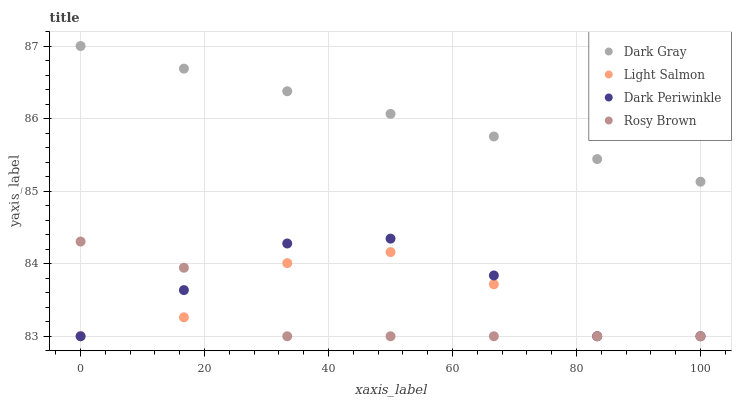Does Rosy Brown have the minimum area under the curve?
Answer yes or no. Yes. Does Dark Gray have the maximum area under the curve?
Answer yes or no. Yes. Does Light Salmon have the minimum area under the curve?
Answer yes or no. No. Does Light Salmon have the maximum area under the curve?
Answer yes or no. No. Is Dark Gray the smoothest?
Answer yes or no. Yes. Is Light Salmon the roughest?
Answer yes or no. Yes. Is Rosy Brown the smoothest?
Answer yes or no. No. Is Rosy Brown the roughest?
Answer yes or no. No. Does Light Salmon have the lowest value?
Answer yes or no. Yes. Does Dark Gray have the highest value?
Answer yes or no. Yes. Does Rosy Brown have the highest value?
Answer yes or no. No. Is Light Salmon less than Dark Gray?
Answer yes or no. Yes. Is Dark Gray greater than Dark Periwinkle?
Answer yes or no. Yes. Does Light Salmon intersect Dark Periwinkle?
Answer yes or no. Yes. Is Light Salmon less than Dark Periwinkle?
Answer yes or no. No. Is Light Salmon greater than Dark Periwinkle?
Answer yes or no. No. Does Light Salmon intersect Dark Gray?
Answer yes or no. No. 